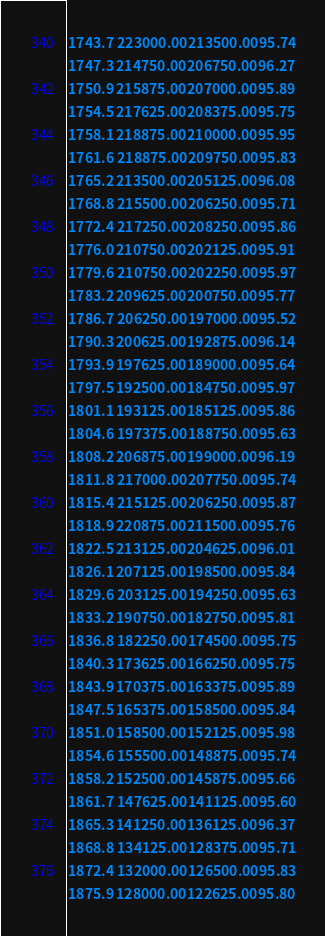<code> <loc_0><loc_0><loc_500><loc_500><_SML_>1743.7  223000.00  213500.00  95.74
1747.3  214750.00  206750.00  96.27
1750.9  215875.00  207000.00  95.89
1754.5  217625.00  208375.00  95.75
1758.1  218875.00  210000.00  95.95
1761.6  218875.00  209750.00  95.83
1765.2  213500.00  205125.00  96.08
1768.8  215500.00  206250.00  95.71
1772.4  217250.00  208250.00  95.86
1776.0  210750.00  202125.00  95.91
1779.6  210750.00  202250.00  95.97
1783.2  209625.00  200750.00  95.77
1786.7  206250.00  197000.00  95.52
1790.3  200625.00  192875.00  96.14
1793.9  197625.00  189000.00  95.64
1797.5  192500.00  184750.00  95.97
1801.1  193125.00  185125.00  95.86
1804.6  197375.00  188750.00  95.63
1808.2  206875.00  199000.00  96.19
1811.8  217000.00  207750.00  95.74
1815.4  215125.00  206250.00  95.87
1818.9  220875.00  211500.00  95.76
1822.5  213125.00  204625.00  96.01
1826.1  207125.00  198500.00  95.84
1829.6  203125.00  194250.00  95.63
1833.2  190750.00  182750.00  95.81
1836.8  182250.00  174500.00  95.75
1840.3  173625.00  166250.00  95.75
1843.9  170375.00  163375.00  95.89
1847.5  165375.00  158500.00  95.84
1851.0  158500.00  152125.00  95.98
1854.6  155500.00  148875.00  95.74
1858.2  152500.00  145875.00  95.66
1861.7  147625.00  141125.00  95.60
1865.3  141250.00  136125.00  96.37
1868.8  134125.00  128375.00  95.71
1872.4  132000.00  126500.00  95.83
1875.9  128000.00  122625.00  95.80</code> 